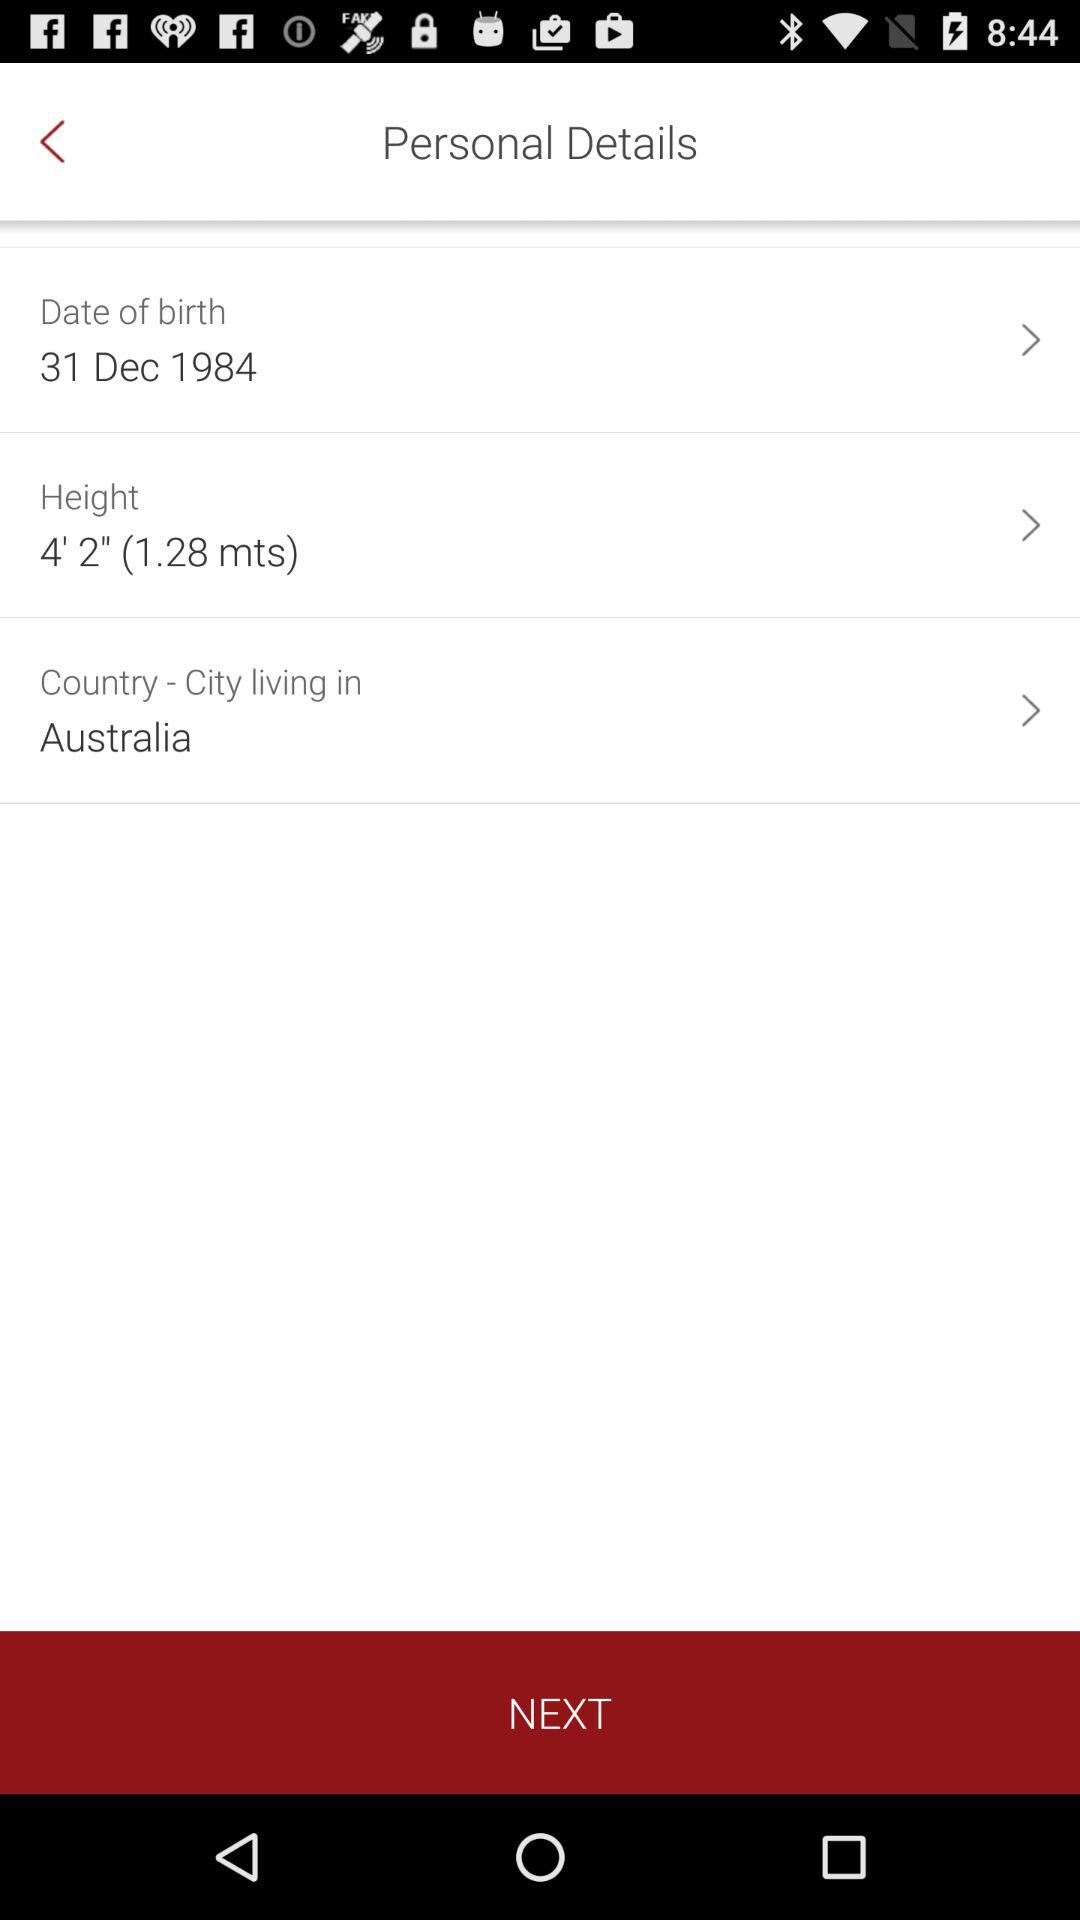What is the country name? The country name is Australia. 